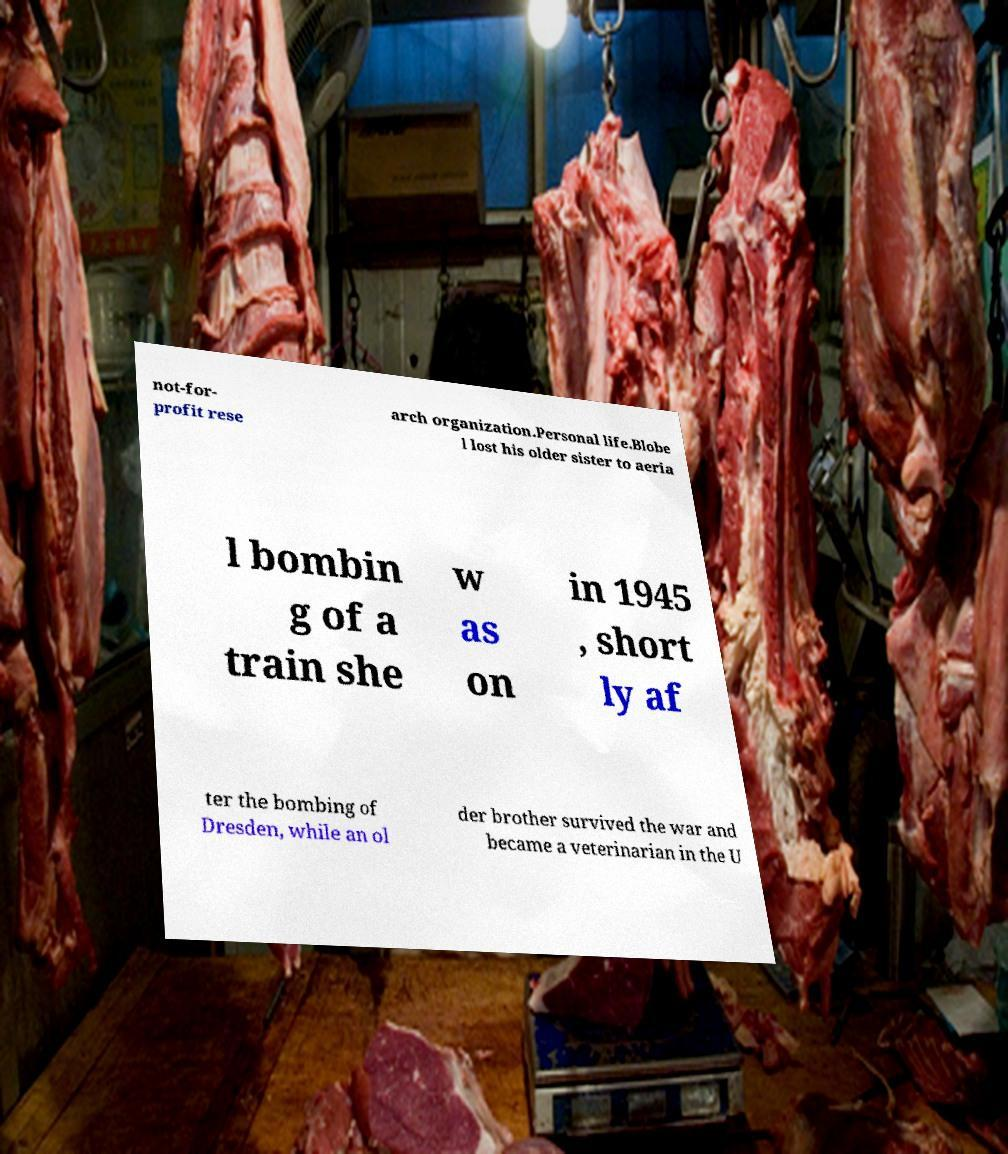What messages or text are displayed in this image? I need them in a readable, typed format. not-for- profit rese arch organization.Personal life.Blobe l lost his older sister to aeria l bombin g of a train she w as on in 1945 , short ly af ter the bombing of Dresden, while an ol der brother survived the war and became a veterinarian in the U 